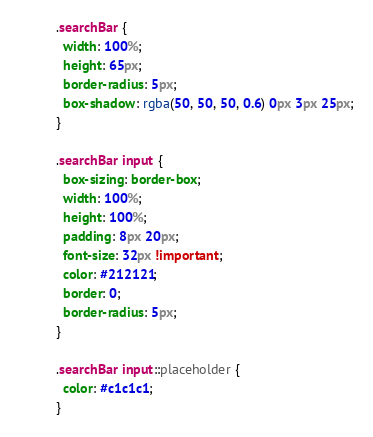Convert code to text. <code><loc_0><loc_0><loc_500><loc_500><_CSS_>.searchBar {
  width: 100%;
  height: 65px;
  border-radius: 5px;
  box-shadow: rgba(50, 50, 50, 0.6) 0px 3px 25px;
}

.searchBar input {
  box-sizing: border-box;
  width: 100%;
  height: 100%;
  padding: 8px 20px;
  font-size: 32px !important;
  color: #212121;
  border: 0;
  border-radius: 5px;
}

.searchBar input::placeholder {
  color: #c1c1c1;
}
</code> 